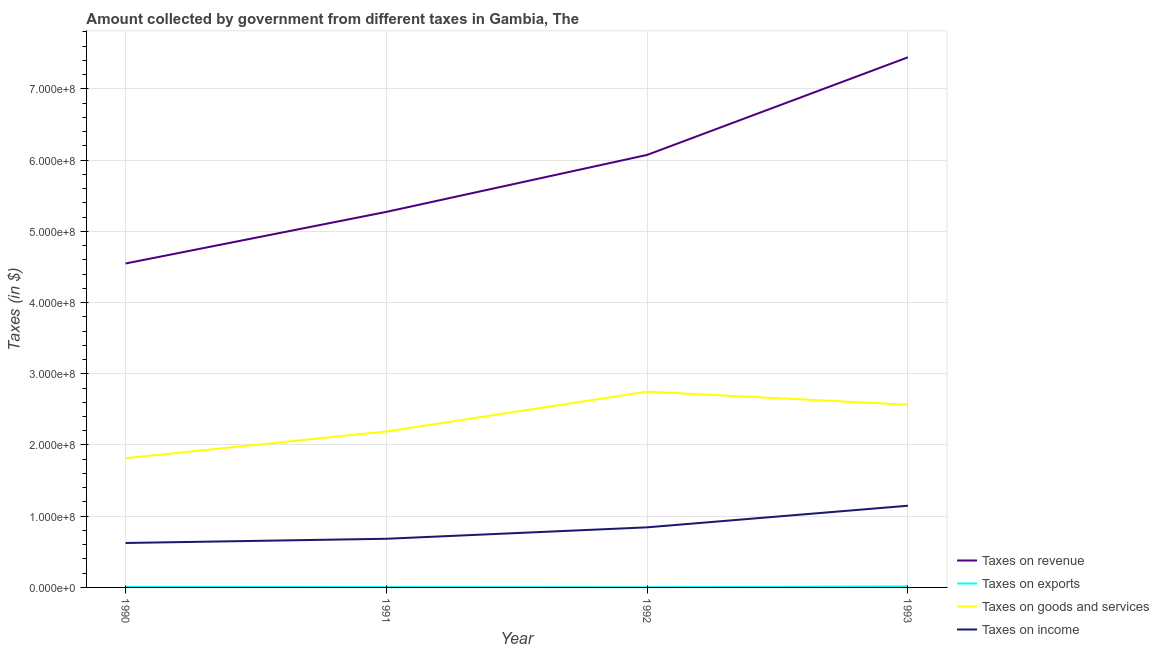Does the line corresponding to amount collected as tax on goods intersect with the line corresponding to amount collected as tax on income?
Make the answer very short. No. What is the amount collected as tax on goods in 1992?
Your response must be concise. 2.75e+08. Across all years, what is the maximum amount collected as tax on goods?
Keep it short and to the point. 2.75e+08. Across all years, what is the minimum amount collected as tax on exports?
Offer a terse response. 3.20e+05. In which year was the amount collected as tax on goods maximum?
Give a very brief answer. 1992. What is the total amount collected as tax on goods in the graph?
Offer a very short reply. 9.32e+08. What is the difference between the amount collected as tax on exports in 1991 and that in 1993?
Offer a very short reply. -9.50e+05. What is the difference between the amount collected as tax on revenue in 1991 and the amount collected as tax on income in 1990?
Provide a succinct answer. 4.65e+08. What is the average amount collected as tax on income per year?
Provide a short and direct response. 8.24e+07. In the year 1993, what is the difference between the amount collected as tax on income and amount collected as tax on exports?
Give a very brief answer. 1.13e+08. In how many years, is the amount collected as tax on revenue greater than 640000000 $?
Give a very brief answer. 1. What is the ratio of the amount collected as tax on exports in 1992 to that in 1993?
Offer a terse response. 0.22. Is the amount collected as tax on exports in 1991 less than that in 1992?
Provide a short and direct response. No. Is the difference between the amount collected as tax on income in 1992 and 1993 greater than the difference between the amount collected as tax on revenue in 1992 and 1993?
Your response must be concise. Yes. What is the difference between the highest and the lowest amount collected as tax on exports?
Provide a succinct answer. 1.13e+06. Is it the case that in every year, the sum of the amount collected as tax on exports and amount collected as tax on goods is greater than the sum of amount collected as tax on revenue and amount collected as tax on income?
Give a very brief answer. No. Does the amount collected as tax on income monotonically increase over the years?
Keep it short and to the point. Yes. How many years are there in the graph?
Provide a short and direct response. 4. What is the difference between two consecutive major ticks on the Y-axis?
Keep it short and to the point. 1.00e+08. Are the values on the major ticks of Y-axis written in scientific E-notation?
Offer a terse response. Yes. How are the legend labels stacked?
Offer a terse response. Vertical. What is the title of the graph?
Give a very brief answer. Amount collected by government from different taxes in Gambia, The. Does "Greece" appear as one of the legend labels in the graph?
Provide a succinct answer. No. What is the label or title of the Y-axis?
Provide a short and direct response. Taxes (in $). What is the Taxes (in $) of Taxes on revenue in 1990?
Your answer should be compact. 4.55e+08. What is the Taxes (in $) in Taxes on goods and services in 1990?
Your answer should be compact. 1.81e+08. What is the Taxes (in $) of Taxes on income in 1990?
Your answer should be very brief. 6.24e+07. What is the Taxes (in $) of Taxes on revenue in 1991?
Offer a terse response. 5.27e+08. What is the Taxes (in $) in Taxes on goods and services in 1991?
Offer a very short reply. 2.19e+08. What is the Taxes (in $) in Taxes on income in 1991?
Offer a terse response. 6.83e+07. What is the Taxes (in $) in Taxes on revenue in 1992?
Give a very brief answer. 6.07e+08. What is the Taxes (in $) of Taxes on goods and services in 1992?
Your answer should be compact. 2.75e+08. What is the Taxes (in $) in Taxes on income in 1992?
Ensure brevity in your answer.  8.44e+07. What is the Taxes (in $) of Taxes on revenue in 1993?
Your answer should be very brief. 7.44e+08. What is the Taxes (in $) in Taxes on exports in 1993?
Provide a succinct answer. 1.45e+06. What is the Taxes (in $) in Taxes on goods and services in 1993?
Offer a very short reply. 2.57e+08. What is the Taxes (in $) of Taxes on income in 1993?
Offer a very short reply. 1.15e+08. Across all years, what is the maximum Taxes (in $) in Taxes on revenue?
Offer a very short reply. 7.44e+08. Across all years, what is the maximum Taxes (in $) of Taxes on exports?
Provide a succinct answer. 1.45e+06. Across all years, what is the maximum Taxes (in $) of Taxes on goods and services?
Your response must be concise. 2.75e+08. Across all years, what is the maximum Taxes (in $) in Taxes on income?
Give a very brief answer. 1.15e+08. Across all years, what is the minimum Taxes (in $) in Taxes on revenue?
Your answer should be compact. 4.55e+08. Across all years, what is the minimum Taxes (in $) in Taxes on exports?
Give a very brief answer. 3.20e+05. Across all years, what is the minimum Taxes (in $) in Taxes on goods and services?
Give a very brief answer. 1.81e+08. Across all years, what is the minimum Taxes (in $) of Taxes on income?
Provide a short and direct response. 6.24e+07. What is the total Taxes (in $) in Taxes on revenue in the graph?
Provide a short and direct response. 2.33e+09. What is the total Taxes (in $) in Taxes on exports in the graph?
Offer a very short reply. 3.17e+06. What is the total Taxes (in $) of Taxes on goods and services in the graph?
Offer a terse response. 9.32e+08. What is the total Taxes (in $) of Taxes on income in the graph?
Offer a terse response. 3.30e+08. What is the difference between the Taxes (in $) of Taxes on revenue in 1990 and that in 1991?
Offer a very short reply. -7.25e+07. What is the difference between the Taxes (in $) in Taxes on exports in 1990 and that in 1991?
Offer a very short reply. 4.00e+05. What is the difference between the Taxes (in $) of Taxes on goods and services in 1990 and that in 1991?
Offer a terse response. -3.75e+07. What is the difference between the Taxes (in $) in Taxes on income in 1990 and that in 1991?
Your answer should be very brief. -5.93e+06. What is the difference between the Taxes (in $) in Taxes on revenue in 1990 and that in 1992?
Your response must be concise. -1.52e+08. What is the difference between the Taxes (in $) of Taxes on exports in 1990 and that in 1992?
Your answer should be very brief. 5.80e+05. What is the difference between the Taxes (in $) of Taxes on goods and services in 1990 and that in 1992?
Offer a terse response. -9.34e+07. What is the difference between the Taxes (in $) in Taxes on income in 1990 and that in 1992?
Your response must be concise. -2.20e+07. What is the difference between the Taxes (in $) in Taxes on revenue in 1990 and that in 1993?
Ensure brevity in your answer.  -2.90e+08. What is the difference between the Taxes (in $) of Taxes on exports in 1990 and that in 1993?
Provide a succinct answer. -5.50e+05. What is the difference between the Taxes (in $) in Taxes on goods and services in 1990 and that in 1993?
Make the answer very short. -7.51e+07. What is the difference between the Taxes (in $) in Taxes on income in 1990 and that in 1993?
Keep it short and to the point. -5.23e+07. What is the difference between the Taxes (in $) in Taxes on revenue in 1991 and that in 1992?
Ensure brevity in your answer.  -8.00e+07. What is the difference between the Taxes (in $) in Taxes on exports in 1991 and that in 1992?
Offer a very short reply. 1.80e+05. What is the difference between the Taxes (in $) of Taxes on goods and services in 1991 and that in 1992?
Offer a terse response. -5.59e+07. What is the difference between the Taxes (in $) in Taxes on income in 1991 and that in 1992?
Give a very brief answer. -1.60e+07. What is the difference between the Taxes (in $) of Taxes on revenue in 1991 and that in 1993?
Your answer should be very brief. -2.17e+08. What is the difference between the Taxes (in $) of Taxes on exports in 1991 and that in 1993?
Keep it short and to the point. -9.50e+05. What is the difference between the Taxes (in $) in Taxes on goods and services in 1991 and that in 1993?
Provide a succinct answer. -3.76e+07. What is the difference between the Taxes (in $) of Taxes on income in 1991 and that in 1993?
Make the answer very short. -4.64e+07. What is the difference between the Taxes (in $) of Taxes on revenue in 1992 and that in 1993?
Make the answer very short. -1.37e+08. What is the difference between the Taxes (in $) of Taxes on exports in 1992 and that in 1993?
Your response must be concise. -1.13e+06. What is the difference between the Taxes (in $) in Taxes on goods and services in 1992 and that in 1993?
Offer a very short reply. 1.83e+07. What is the difference between the Taxes (in $) of Taxes on income in 1992 and that in 1993?
Your answer should be very brief. -3.03e+07. What is the difference between the Taxes (in $) in Taxes on revenue in 1990 and the Taxes (in $) in Taxes on exports in 1991?
Give a very brief answer. 4.54e+08. What is the difference between the Taxes (in $) of Taxes on revenue in 1990 and the Taxes (in $) of Taxes on goods and services in 1991?
Give a very brief answer. 2.36e+08. What is the difference between the Taxes (in $) in Taxes on revenue in 1990 and the Taxes (in $) in Taxes on income in 1991?
Give a very brief answer. 3.86e+08. What is the difference between the Taxes (in $) of Taxes on exports in 1990 and the Taxes (in $) of Taxes on goods and services in 1991?
Offer a terse response. -2.18e+08. What is the difference between the Taxes (in $) of Taxes on exports in 1990 and the Taxes (in $) of Taxes on income in 1991?
Your response must be concise. -6.74e+07. What is the difference between the Taxes (in $) in Taxes on goods and services in 1990 and the Taxes (in $) in Taxes on income in 1991?
Give a very brief answer. 1.13e+08. What is the difference between the Taxes (in $) in Taxes on revenue in 1990 and the Taxes (in $) in Taxes on exports in 1992?
Provide a short and direct response. 4.54e+08. What is the difference between the Taxes (in $) of Taxes on revenue in 1990 and the Taxes (in $) of Taxes on goods and services in 1992?
Give a very brief answer. 1.80e+08. What is the difference between the Taxes (in $) of Taxes on revenue in 1990 and the Taxes (in $) of Taxes on income in 1992?
Make the answer very short. 3.70e+08. What is the difference between the Taxes (in $) of Taxes on exports in 1990 and the Taxes (in $) of Taxes on goods and services in 1992?
Offer a terse response. -2.74e+08. What is the difference between the Taxes (in $) of Taxes on exports in 1990 and the Taxes (in $) of Taxes on income in 1992?
Provide a succinct answer. -8.35e+07. What is the difference between the Taxes (in $) of Taxes on goods and services in 1990 and the Taxes (in $) of Taxes on income in 1992?
Make the answer very short. 9.71e+07. What is the difference between the Taxes (in $) in Taxes on revenue in 1990 and the Taxes (in $) in Taxes on exports in 1993?
Provide a succinct answer. 4.53e+08. What is the difference between the Taxes (in $) of Taxes on revenue in 1990 and the Taxes (in $) of Taxes on goods and services in 1993?
Your answer should be very brief. 1.98e+08. What is the difference between the Taxes (in $) in Taxes on revenue in 1990 and the Taxes (in $) in Taxes on income in 1993?
Provide a succinct answer. 3.40e+08. What is the difference between the Taxes (in $) of Taxes on exports in 1990 and the Taxes (in $) of Taxes on goods and services in 1993?
Provide a short and direct response. -2.56e+08. What is the difference between the Taxes (in $) in Taxes on exports in 1990 and the Taxes (in $) in Taxes on income in 1993?
Your answer should be compact. -1.14e+08. What is the difference between the Taxes (in $) of Taxes on goods and services in 1990 and the Taxes (in $) of Taxes on income in 1993?
Provide a short and direct response. 6.68e+07. What is the difference between the Taxes (in $) of Taxes on revenue in 1991 and the Taxes (in $) of Taxes on exports in 1992?
Ensure brevity in your answer.  5.27e+08. What is the difference between the Taxes (in $) of Taxes on revenue in 1991 and the Taxes (in $) of Taxes on goods and services in 1992?
Your answer should be very brief. 2.52e+08. What is the difference between the Taxes (in $) of Taxes on revenue in 1991 and the Taxes (in $) of Taxes on income in 1992?
Ensure brevity in your answer.  4.43e+08. What is the difference between the Taxes (in $) of Taxes on exports in 1991 and the Taxes (in $) of Taxes on goods and services in 1992?
Give a very brief answer. -2.74e+08. What is the difference between the Taxes (in $) of Taxes on exports in 1991 and the Taxes (in $) of Taxes on income in 1992?
Your answer should be compact. -8.39e+07. What is the difference between the Taxes (in $) in Taxes on goods and services in 1991 and the Taxes (in $) in Taxes on income in 1992?
Offer a very short reply. 1.35e+08. What is the difference between the Taxes (in $) of Taxes on revenue in 1991 and the Taxes (in $) of Taxes on exports in 1993?
Keep it short and to the point. 5.26e+08. What is the difference between the Taxes (in $) of Taxes on revenue in 1991 and the Taxes (in $) of Taxes on goods and services in 1993?
Offer a terse response. 2.71e+08. What is the difference between the Taxes (in $) of Taxes on revenue in 1991 and the Taxes (in $) of Taxes on income in 1993?
Offer a terse response. 4.13e+08. What is the difference between the Taxes (in $) in Taxes on exports in 1991 and the Taxes (in $) in Taxes on goods and services in 1993?
Make the answer very short. -2.56e+08. What is the difference between the Taxes (in $) of Taxes on exports in 1991 and the Taxes (in $) of Taxes on income in 1993?
Ensure brevity in your answer.  -1.14e+08. What is the difference between the Taxes (in $) in Taxes on goods and services in 1991 and the Taxes (in $) in Taxes on income in 1993?
Your answer should be compact. 1.04e+08. What is the difference between the Taxes (in $) of Taxes on revenue in 1992 and the Taxes (in $) of Taxes on exports in 1993?
Provide a succinct answer. 6.06e+08. What is the difference between the Taxes (in $) in Taxes on revenue in 1992 and the Taxes (in $) in Taxes on goods and services in 1993?
Provide a short and direct response. 3.51e+08. What is the difference between the Taxes (in $) of Taxes on revenue in 1992 and the Taxes (in $) of Taxes on income in 1993?
Offer a terse response. 4.93e+08. What is the difference between the Taxes (in $) in Taxes on exports in 1992 and the Taxes (in $) in Taxes on goods and services in 1993?
Offer a very short reply. -2.56e+08. What is the difference between the Taxes (in $) in Taxes on exports in 1992 and the Taxes (in $) in Taxes on income in 1993?
Your answer should be very brief. -1.14e+08. What is the difference between the Taxes (in $) of Taxes on goods and services in 1992 and the Taxes (in $) of Taxes on income in 1993?
Provide a short and direct response. 1.60e+08. What is the average Taxes (in $) of Taxes on revenue per year?
Offer a very short reply. 5.83e+08. What is the average Taxes (in $) of Taxes on exports per year?
Your response must be concise. 7.92e+05. What is the average Taxes (in $) in Taxes on goods and services per year?
Give a very brief answer. 2.33e+08. What is the average Taxes (in $) of Taxes on income per year?
Make the answer very short. 8.24e+07. In the year 1990, what is the difference between the Taxes (in $) in Taxes on revenue and Taxes (in $) in Taxes on exports?
Provide a succinct answer. 4.54e+08. In the year 1990, what is the difference between the Taxes (in $) in Taxes on revenue and Taxes (in $) in Taxes on goods and services?
Offer a terse response. 2.73e+08. In the year 1990, what is the difference between the Taxes (in $) in Taxes on revenue and Taxes (in $) in Taxes on income?
Your answer should be compact. 3.92e+08. In the year 1990, what is the difference between the Taxes (in $) of Taxes on exports and Taxes (in $) of Taxes on goods and services?
Your response must be concise. -1.81e+08. In the year 1990, what is the difference between the Taxes (in $) in Taxes on exports and Taxes (in $) in Taxes on income?
Offer a terse response. -6.15e+07. In the year 1990, what is the difference between the Taxes (in $) of Taxes on goods and services and Taxes (in $) of Taxes on income?
Give a very brief answer. 1.19e+08. In the year 1991, what is the difference between the Taxes (in $) of Taxes on revenue and Taxes (in $) of Taxes on exports?
Offer a terse response. 5.27e+08. In the year 1991, what is the difference between the Taxes (in $) in Taxes on revenue and Taxes (in $) in Taxes on goods and services?
Offer a terse response. 3.08e+08. In the year 1991, what is the difference between the Taxes (in $) of Taxes on revenue and Taxes (in $) of Taxes on income?
Ensure brevity in your answer.  4.59e+08. In the year 1991, what is the difference between the Taxes (in $) of Taxes on exports and Taxes (in $) of Taxes on goods and services?
Your answer should be compact. -2.18e+08. In the year 1991, what is the difference between the Taxes (in $) in Taxes on exports and Taxes (in $) in Taxes on income?
Offer a terse response. -6.78e+07. In the year 1991, what is the difference between the Taxes (in $) in Taxes on goods and services and Taxes (in $) in Taxes on income?
Offer a terse response. 1.51e+08. In the year 1992, what is the difference between the Taxes (in $) in Taxes on revenue and Taxes (in $) in Taxes on exports?
Ensure brevity in your answer.  6.07e+08. In the year 1992, what is the difference between the Taxes (in $) in Taxes on revenue and Taxes (in $) in Taxes on goods and services?
Give a very brief answer. 3.32e+08. In the year 1992, what is the difference between the Taxes (in $) of Taxes on revenue and Taxes (in $) of Taxes on income?
Ensure brevity in your answer.  5.23e+08. In the year 1992, what is the difference between the Taxes (in $) of Taxes on exports and Taxes (in $) of Taxes on goods and services?
Offer a very short reply. -2.75e+08. In the year 1992, what is the difference between the Taxes (in $) of Taxes on exports and Taxes (in $) of Taxes on income?
Ensure brevity in your answer.  -8.40e+07. In the year 1992, what is the difference between the Taxes (in $) in Taxes on goods and services and Taxes (in $) in Taxes on income?
Your response must be concise. 1.91e+08. In the year 1993, what is the difference between the Taxes (in $) of Taxes on revenue and Taxes (in $) of Taxes on exports?
Provide a short and direct response. 7.43e+08. In the year 1993, what is the difference between the Taxes (in $) of Taxes on revenue and Taxes (in $) of Taxes on goods and services?
Your answer should be compact. 4.88e+08. In the year 1993, what is the difference between the Taxes (in $) of Taxes on revenue and Taxes (in $) of Taxes on income?
Your answer should be compact. 6.30e+08. In the year 1993, what is the difference between the Taxes (in $) in Taxes on exports and Taxes (in $) in Taxes on goods and services?
Offer a terse response. -2.55e+08. In the year 1993, what is the difference between the Taxes (in $) of Taxes on exports and Taxes (in $) of Taxes on income?
Give a very brief answer. -1.13e+08. In the year 1993, what is the difference between the Taxes (in $) of Taxes on goods and services and Taxes (in $) of Taxes on income?
Make the answer very short. 1.42e+08. What is the ratio of the Taxes (in $) of Taxes on revenue in 1990 to that in 1991?
Make the answer very short. 0.86. What is the ratio of the Taxes (in $) in Taxes on goods and services in 1990 to that in 1991?
Ensure brevity in your answer.  0.83. What is the ratio of the Taxes (in $) in Taxes on income in 1990 to that in 1991?
Your answer should be very brief. 0.91. What is the ratio of the Taxes (in $) in Taxes on revenue in 1990 to that in 1992?
Offer a very short reply. 0.75. What is the ratio of the Taxes (in $) of Taxes on exports in 1990 to that in 1992?
Make the answer very short. 2.81. What is the ratio of the Taxes (in $) in Taxes on goods and services in 1990 to that in 1992?
Provide a short and direct response. 0.66. What is the ratio of the Taxes (in $) in Taxes on income in 1990 to that in 1992?
Offer a terse response. 0.74. What is the ratio of the Taxes (in $) of Taxes on revenue in 1990 to that in 1993?
Keep it short and to the point. 0.61. What is the ratio of the Taxes (in $) of Taxes on exports in 1990 to that in 1993?
Offer a very short reply. 0.62. What is the ratio of the Taxes (in $) of Taxes on goods and services in 1990 to that in 1993?
Your response must be concise. 0.71. What is the ratio of the Taxes (in $) of Taxes on income in 1990 to that in 1993?
Ensure brevity in your answer.  0.54. What is the ratio of the Taxes (in $) in Taxes on revenue in 1991 to that in 1992?
Your answer should be very brief. 0.87. What is the ratio of the Taxes (in $) in Taxes on exports in 1991 to that in 1992?
Offer a terse response. 1.56. What is the ratio of the Taxes (in $) of Taxes on goods and services in 1991 to that in 1992?
Ensure brevity in your answer.  0.8. What is the ratio of the Taxes (in $) in Taxes on income in 1991 to that in 1992?
Offer a terse response. 0.81. What is the ratio of the Taxes (in $) in Taxes on revenue in 1991 to that in 1993?
Your answer should be compact. 0.71. What is the ratio of the Taxes (in $) of Taxes on exports in 1991 to that in 1993?
Your answer should be compact. 0.34. What is the ratio of the Taxes (in $) in Taxes on goods and services in 1991 to that in 1993?
Offer a terse response. 0.85. What is the ratio of the Taxes (in $) of Taxes on income in 1991 to that in 1993?
Offer a terse response. 0.6. What is the ratio of the Taxes (in $) of Taxes on revenue in 1992 to that in 1993?
Your answer should be very brief. 0.82. What is the ratio of the Taxes (in $) of Taxes on exports in 1992 to that in 1993?
Give a very brief answer. 0.22. What is the ratio of the Taxes (in $) in Taxes on goods and services in 1992 to that in 1993?
Keep it short and to the point. 1.07. What is the ratio of the Taxes (in $) in Taxes on income in 1992 to that in 1993?
Keep it short and to the point. 0.74. What is the difference between the highest and the second highest Taxes (in $) of Taxes on revenue?
Offer a terse response. 1.37e+08. What is the difference between the highest and the second highest Taxes (in $) in Taxes on goods and services?
Keep it short and to the point. 1.83e+07. What is the difference between the highest and the second highest Taxes (in $) of Taxes on income?
Your answer should be very brief. 3.03e+07. What is the difference between the highest and the lowest Taxes (in $) in Taxes on revenue?
Provide a short and direct response. 2.90e+08. What is the difference between the highest and the lowest Taxes (in $) in Taxes on exports?
Provide a succinct answer. 1.13e+06. What is the difference between the highest and the lowest Taxes (in $) in Taxes on goods and services?
Your answer should be compact. 9.34e+07. What is the difference between the highest and the lowest Taxes (in $) of Taxes on income?
Offer a terse response. 5.23e+07. 